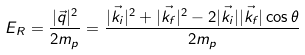<formula> <loc_0><loc_0><loc_500><loc_500>E _ { R } = \frac { | \vec { q } | ^ { 2 } } { 2 m _ { p } } = \frac { | \vec { k _ { i } } | ^ { 2 } + | \vec { k _ { f } } | ^ { 2 } - 2 | \vec { k _ { i } } | | \vec { k _ { f } } | \cos \theta } { 2 m _ { p } }</formula> 